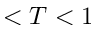<formula> <loc_0><loc_0><loc_500><loc_500>< T < 1</formula> 